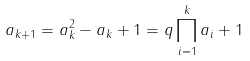Convert formula to latex. <formula><loc_0><loc_0><loc_500><loc_500>a _ { k + 1 } = a _ { k } ^ { 2 } - a _ { k } + 1 = q \prod _ { i = 1 } ^ { k } a _ { i } + 1</formula> 